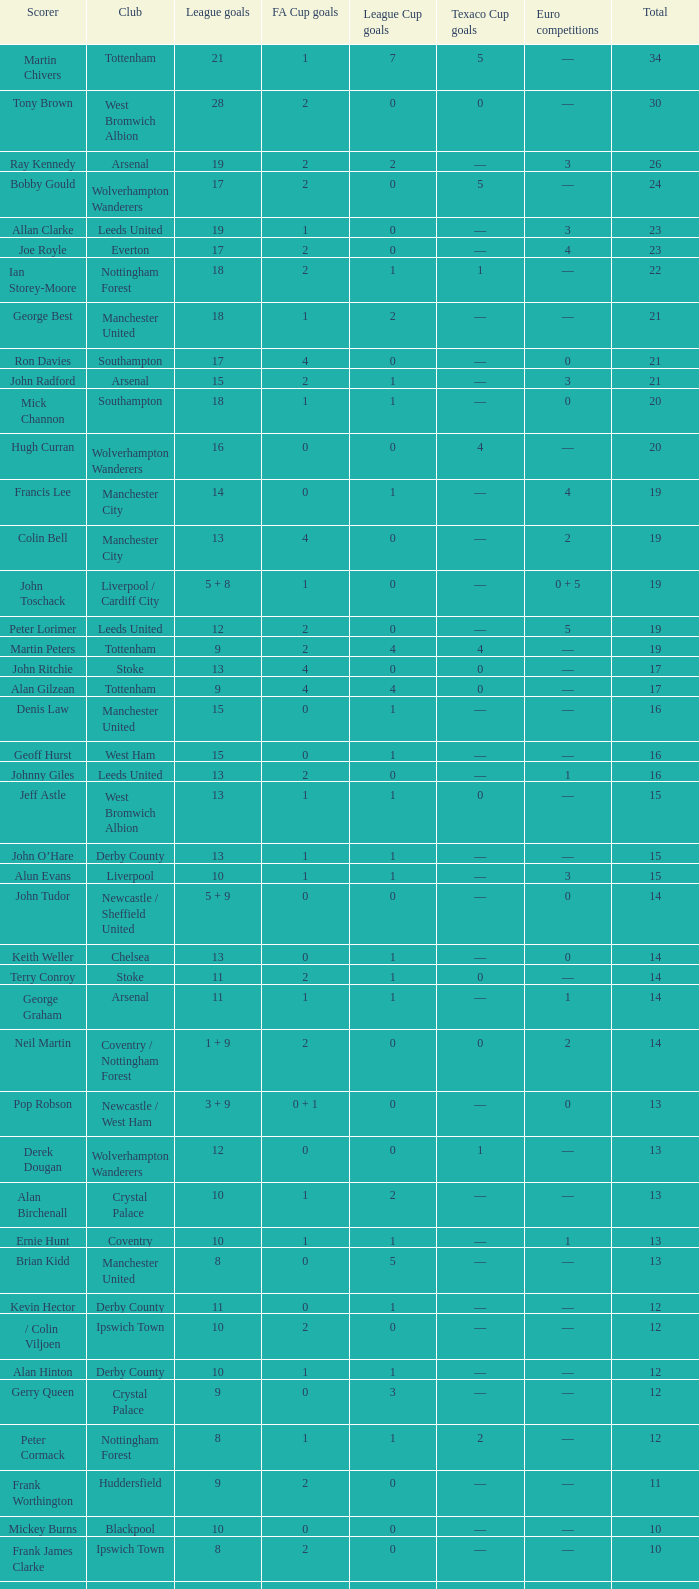What is the total number of Total, when Club is Leeds United, and when League Goals is 13? 1.0. Would you mind parsing the complete table? {'header': ['Scorer', 'Club', 'League goals', 'FA Cup goals', 'League Cup goals', 'Texaco Cup goals', 'Euro competitions', 'Total'], 'rows': [['Martin Chivers', 'Tottenham', '21', '1', '7', '5', '—', '34'], ['Tony Brown', 'West Bromwich Albion', '28', '2', '0', '0', '—', '30'], ['Ray Kennedy', 'Arsenal', '19', '2', '2', '—', '3', '26'], ['Bobby Gould', 'Wolverhampton Wanderers', '17', '2', '0', '5', '—', '24'], ['Allan Clarke', 'Leeds United', '19', '1', '0', '—', '3', '23'], ['Joe Royle', 'Everton', '17', '2', '0', '—', '4', '23'], ['Ian Storey-Moore', 'Nottingham Forest', '18', '2', '1', '1', '—', '22'], ['George Best', 'Manchester United', '18', '1', '2', '—', '—', '21'], ['Ron Davies', 'Southampton', '17', '4', '0', '—', '0', '21'], ['John Radford', 'Arsenal', '15', '2', '1', '—', '3', '21'], ['Mick Channon', 'Southampton', '18', '1', '1', '—', '0', '20'], ['Hugh Curran', 'Wolverhampton Wanderers', '16', '0', '0', '4', '—', '20'], ['Francis Lee', 'Manchester City', '14', '0', '1', '—', '4', '19'], ['Colin Bell', 'Manchester City', '13', '4', '0', '—', '2', '19'], ['John Toschack', 'Liverpool / Cardiff City', '5 + 8', '1', '0', '—', '0 + 5', '19'], ['Peter Lorimer', 'Leeds United', '12', '2', '0', '—', '5', '19'], ['Martin Peters', 'Tottenham', '9', '2', '4', '4', '—', '19'], ['John Ritchie', 'Stoke', '13', '4', '0', '0', '—', '17'], ['Alan Gilzean', 'Tottenham', '9', '4', '4', '0', '—', '17'], ['Denis Law', 'Manchester United', '15', '0', '1', '—', '—', '16'], ['Geoff Hurst', 'West Ham', '15', '0', '1', '—', '—', '16'], ['Johnny Giles', 'Leeds United', '13', '2', '0', '—', '1', '16'], ['Jeff Astle', 'West Bromwich Albion', '13', '1', '1', '0', '—', '15'], ['John O’Hare', 'Derby County', '13', '1', '1', '—', '—', '15'], ['Alun Evans', 'Liverpool', '10', '1', '1', '—', '3', '15'], ['John Tudor', 'Newcastle / Sheffield United', '5 + 9', '0', '0', '—', '0', '14'], ['Keith Weller', 'Chelsea', '13', '0', '1', '—', '0', '14'], ['Terry Conroy', 'Stoke', '11', '2', '1', '0', '—', '14'], ['George Graham', 'Arsenal', '11', '1', '1', '—', '1', '14'], ['Neil Martin', 'Coventry / Nottingham Forest', '1 + 9', '2', '0', '0', '2', '14'], ['Pop Robson', 'Newcastle / West Ham', '3 + 9', '0 + 1', '0', '—', '0', '13'], ['Derek Dougan', 'Wolverhampton Wanderers', '12', '0', '0', '1', '—', '13'], ['Alan Birchenall', 'Crystal Palace', '10', '1', '2', '—', '—', '13'], ['Ernie Hunt', 'Coventry', '10', '1', '1', '—', '1', '13'], ['Brian Kidd', 'Manchester United', '8', '0', '5', '—', '—', '13'], ['Kevin Hector', 'Derby County', '11', '0', '1', '—', '—', '12'], ['/ Colin Viljoen', 'Ipswich Town', '10', '2', '0', '—', '—', '12'], ['Alan Hinton', 'Derby County', '10', '1', '1', '—', '—', '12'], ['Gerry Queen', 'Crystal Palace', '9', '0', '3', '—', '—', '12'], ['Peter Cormack', 'Nottingham Forest', '8', '1', '1', '2', '—', '12'], ['Frank Worthington', 'Huddersfield', '9', '2', '0', '—', '—', '11'], ['Mickey Burns', 'Blackpool', '10', '0', '0', '—', '—', '10'], ['Frank James Clarke', 'Ipswich Town', '8', '2', '0', '—', '—', '10'], ['Jimmy Greenhoff', 'Stoke', '7', '3', '0', '0', '—', '10'], ['Charlie George', 'Arsenal', '5', '5', '0', '—', '0', '10']]} 